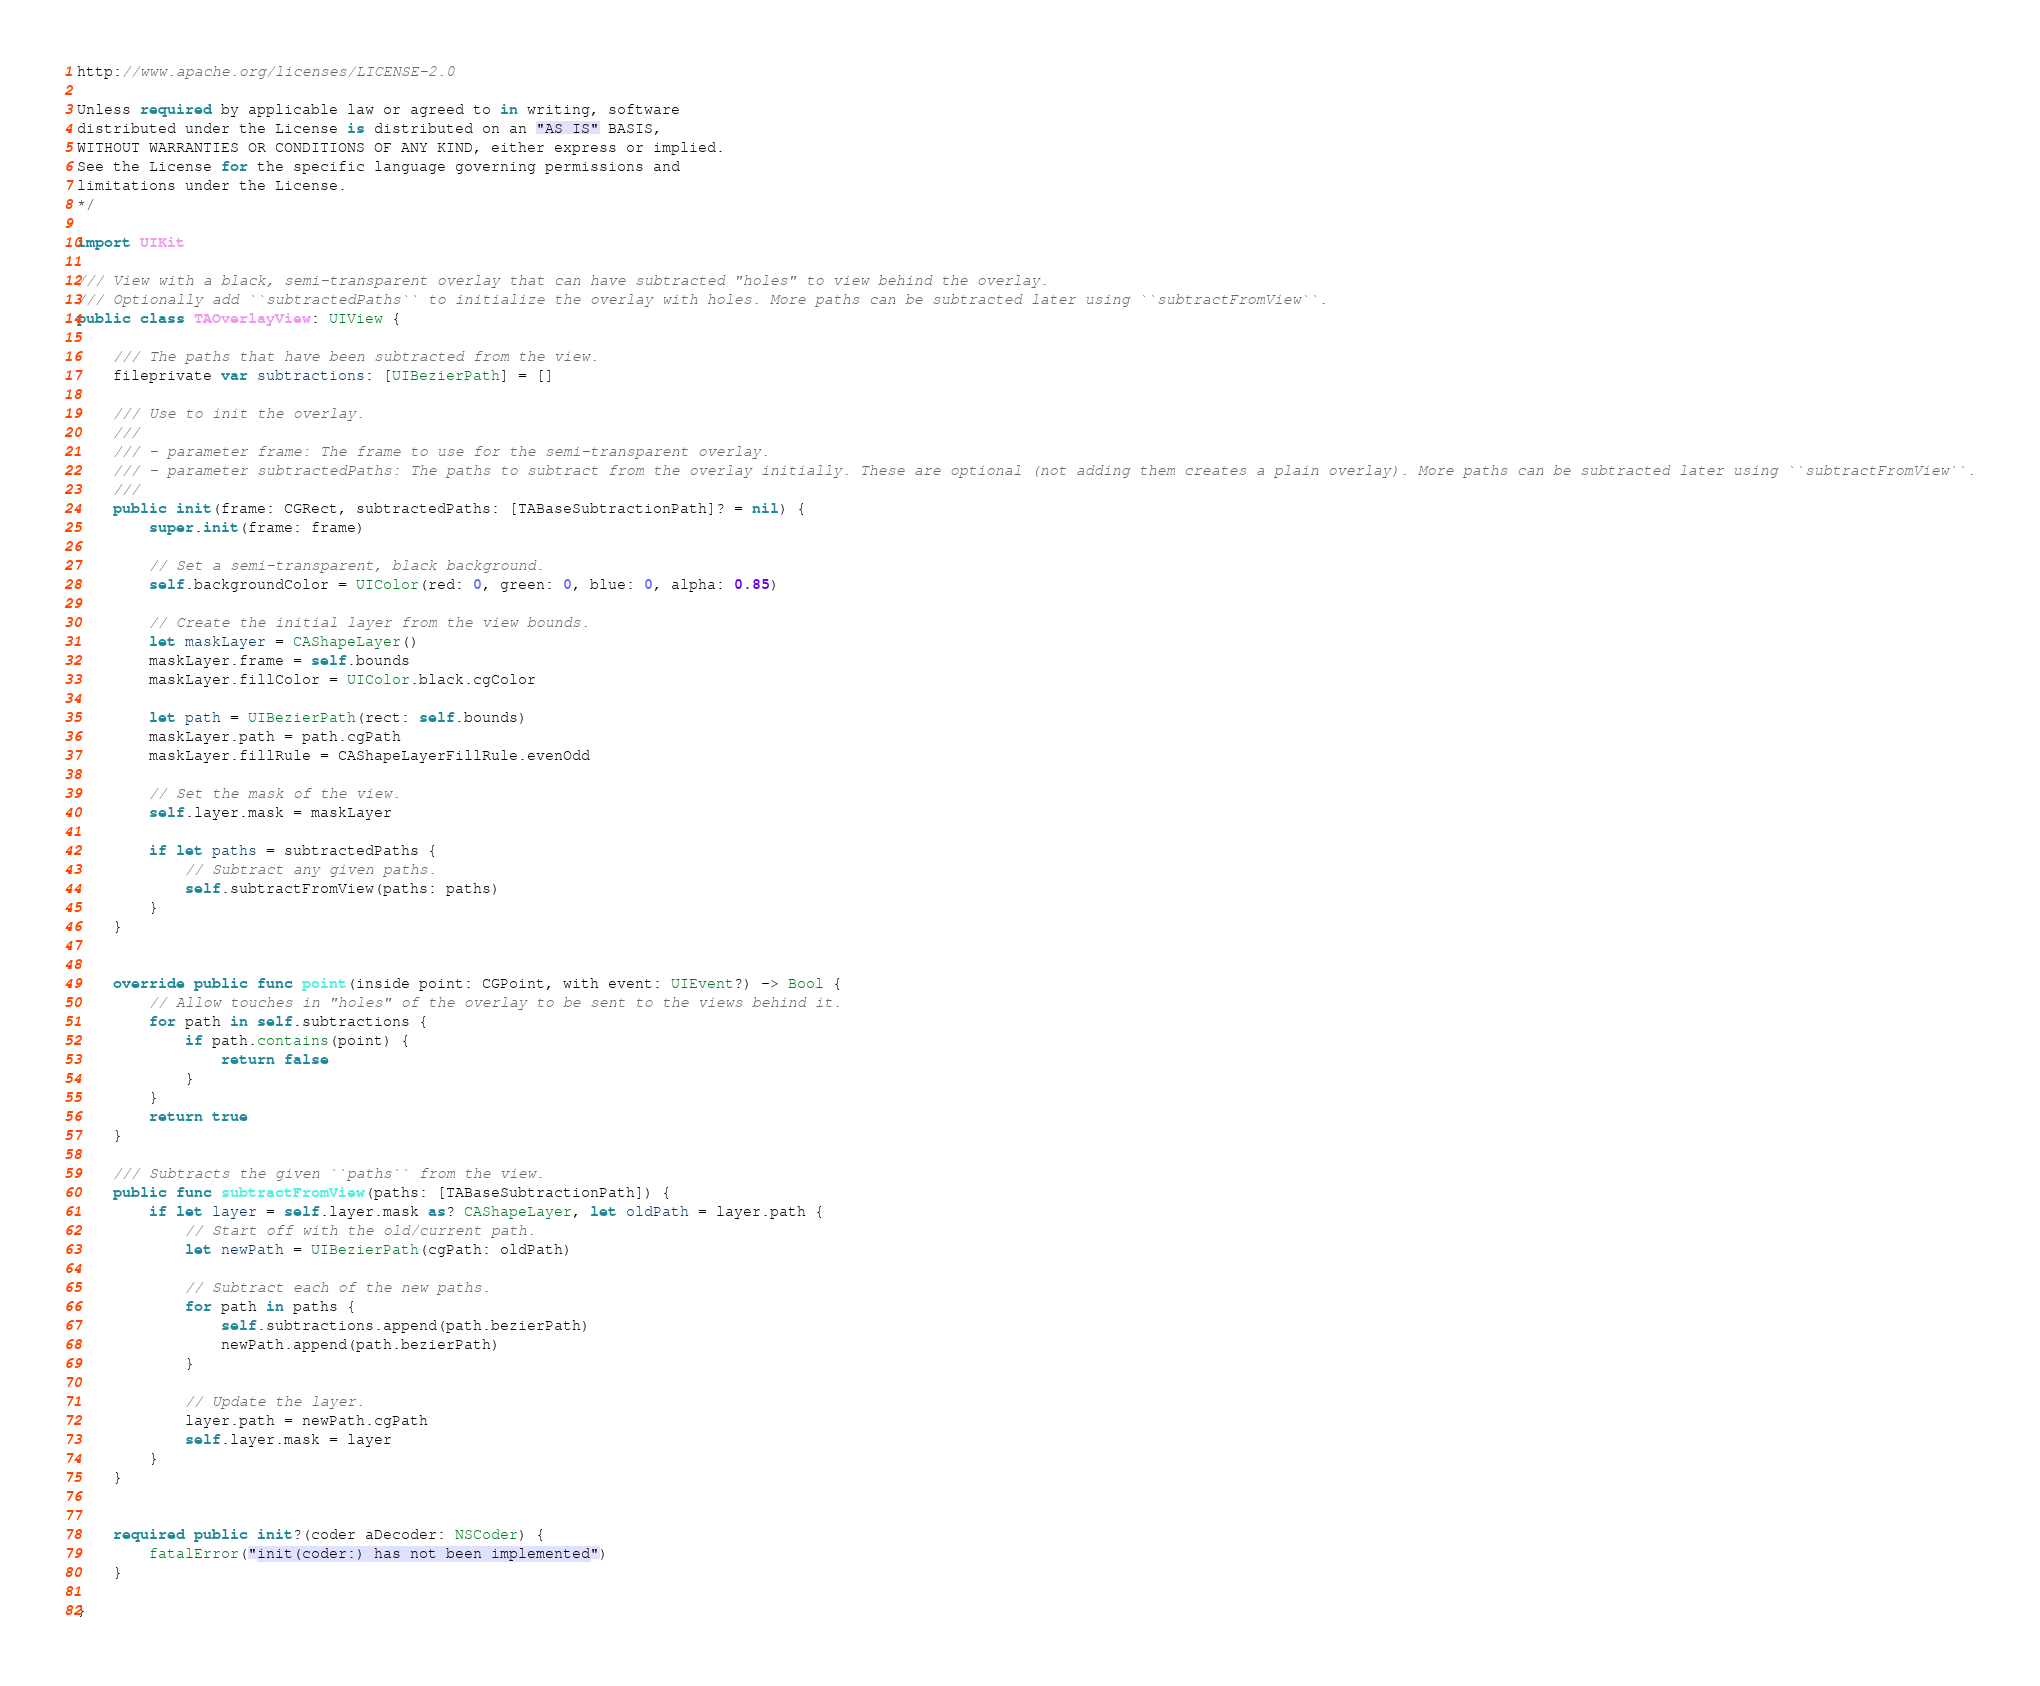<code> <loc_0><loc_0><loc_500><loc_500><_Swift_>
http://www.apache.org/licenses/LICENSE-2.0

Unless required by applicable law or agreed to in writing, software
distributed under the License is distributed on an "AS IS" BASIS,
WITHOUT WARRANTIES OR CONDITIONS OF ANY KIND, either express or implied.
See the License for the specific language governing permissions and
limitations under the License.
*/

import UIKit

/// View with a black, semi-transparent overlay that can have subtracted "holes" to view behind the overlay. 
/// Optionally add ``subtractedPaths`` to initialize the overlay with holes. More paths can be subtracted later using ``subtractFromView``.
public class TAOverlayView: UIView {
    
    /// The paths that have been subtracted from the view.
    fileprivate var subtractions: [UIBezierPath] = []
    
    /// Use to init the overlay.
    ///
    /// - parameter frame: The frame to use for the semi-transparent overlay.
    /// - parameter subtractedPaths: The paths to subtract from the overlay initially. These are optional (not adding them creates a plain overlay). More paths can be subtracted later using ``subtractFromView``.
    ///
    public init(frame: CGRect, subtractedPaths: [TABaseSubtractionPath]? = nil) {
        super.init(frame: frame)
        
        // Set a semi-transparent, black background.
        self.backgroundColor = UIColor(red: 0, green: 0, blue: 0, alpha: 0.85)
        
        // Create the initial layer from the view bounds.
        let maskLayer = CAShapeLayer()
        maskLayer.frame = self.bounds
        maskLayer.fillColor = UIColor.black.cgColor
        
        let path = UIBezierPath(rect: self.bounds)
        maskLayer.path = path.cgPath
        maskLayer.fillRule = CAShapeLayerFillRule.evenOdd
        
        // Set the mask of the view.
        self.layer.mask = maskLayer
        
        if let paths = subtractedPaths {
            // Subtract any given paths.
            self.subtractFromView(paths: paths)
        }
    }


    override public func point(inside point: CGPoint, with event: UIEvent?) -> Bool {
        // Allow touches in "holes" of the overlay to be sent to the views behind it.
        for path in self.subtractions {
            if path.contains(point) {
                return false
            }
        }
        return true
    }
    
    /// Subtracts the given ``paths`` from the view.
    public func subtractFromView(paths: [TABaseSubtractionPath]) {
        if let layer = self.layer.mask as? CAShapeLayer, let oldPath = layer.path {
            // Start off with the old/current path.
            let newPath = UIBezierPath(cgPath: oldPath)
            
            // Subtract each of the new paths.
            for path in paths {
                self.subtractions.append(path.bezierPath)
                newPath.append(path.bezierPath)
            }
            
            // Update the layer.
            layer.path = newPath.cgPath
            self.layer.mask = layer
        }
    }
    
    
    required public init?(coder aDecoder: NSCoder) {
        fatalError("init(coder:) has not been implemented")
    }
    
}
</code> 